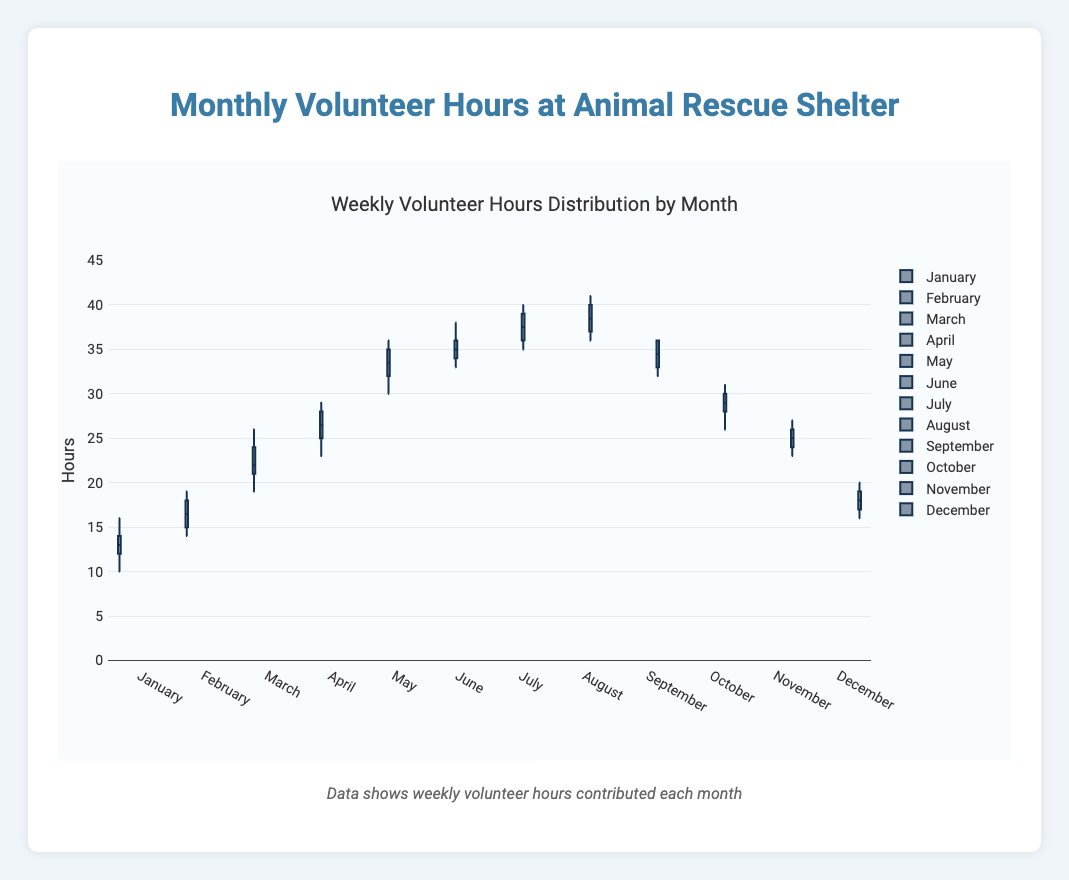What is the title of the plot? The title of the plot is shown at the top. It reads "Weekly Volunteer Hours Distribution by Month".
Answer: Weekly Volunteer Hours Distribution by Month What is the median volunteer hours for January? The median in a box plot is represented by the line inside the box. For January, it's around 13 hours per week.
Answer: 13 Which month has the highest median volunteer hours? The highest median can be seen by identifying the box plot with the highest central line. July has a median of around 37 hours per week, which is the highest.
Answer: July How does the spread of volunteer hours in April compare to September? The spread or interquartile range (IQR) in a box plot is the height of the box. April has a larger IQR compared to September, indicating more variability in volunteer hours.
Answer: April has a larger IQR In which month is there the least variability in volunteer hours? The month with the least variability will have the smallest IQR. October shows the smallest IQR, indicating the least variability in volunteer hours.
Answer: October Which month has the highest upper whisker value, and what is it? The highest upper whisker value can be found by comparing the whiskers of each box plot. August has the highest upper whisker value, around 41 hours per week.
Answer: August, 41 What is the approximate range of volunteer hours in December? The range is the difference between the highest and lowest values. In December, the highest is around 20 and the lowest is around 16, so the range is approximately 4 hours per week.
Answer: 4 hours Which months have outliers, if any? Outliers are indicated by points outside the whiskers of the box plots. Here, there are no obvious outliers in any month's data.
Answer: None What is the interquartile range (IQR) for May? The IQR is the distance between the lower and upper quartiles (Q1 and Q3). For May, Q1 is around 31 and Q3 is around 35, making the IQR approximately 4 hours per week.
Answer: 4 hours Which month has the lowest median volunteer hours, and what is it? The lowest median can be identified by finding the box plot with the lowest central line. December has the lowest median at around 18 hours per week.
Answer: December, 18 